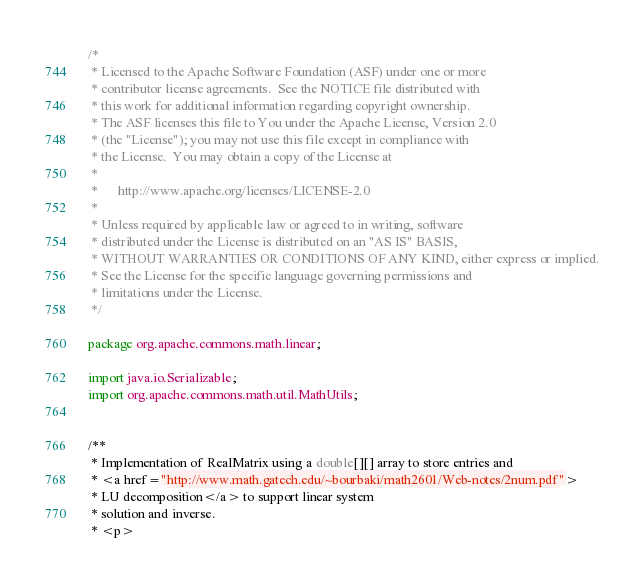Convert code to text. <code><loc_0><loc_0><loc_500><loc_500><_Java_>/*
 * Licensed to the Apache Software Foundation (ASF) under one or more
 * contributor license agreements.  See the NOTICE file distributed with
 * this work for additional information regarding copyright ownership.
 * The ASF licenses this file to You under the Apache License, Version 2.0
 * (the "License"); you may not use this file except in compliance with
 * the License.  You may obtain a copy of the License at
 *
 *      http://www.apache.org/licenses/LICENSE-2.0
 *
 * Unless required by applicable law or agreed to in writing, software
 * distributed under the License is distributed on an "AS IS" BASIS,
 * WITHOUT WARRANTIES OR CONDITIONS OF ANY KIND, either express or implied.
 * See the License for the specific language governing permissions and
 * limitations under the License.
 */

package org.apache.commons.math.linear;

import java.io.Serializable;
import org.apache.commons.math.util.MathUtils;


/**
 * Implementation of RealMatrix using a double[][] array to store entries and
 * <a href="http://www.math.gatech.edu/~bourbaki/math2601/Web-notes/2num.pdf">
 * LU decomposition</a> to support linear system
 * solution and inverse.
 * <p></code> 